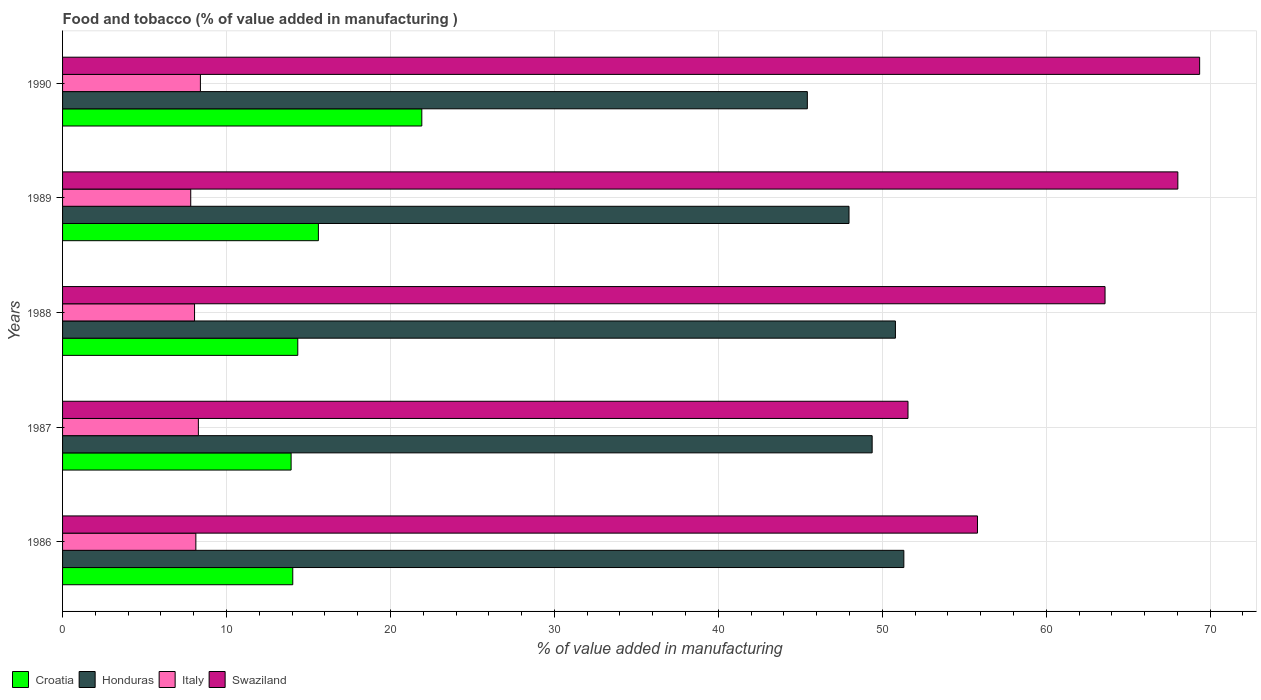Are the number of bars on each tick of the Y-axis equal?
Your answer should be compact. Yes. What is the label of the 5th group of bars from the top?
Keep it short and to the point. 1986. In how many cases, is the number of bars for a given year not equal to the number of legend labels?
Your answer should be compact. 0. What is the value added in manufacturing food and tobacco in Italy in 1988?
Give a very brief answer. 8.05. Across all years, what is the maximum value added in manufacturing food and tobacco in Honduras?
Your answer should be very brief. 51.32. Across all years, what is the minimum value added in manufacturing food and tobacco in Swaziland?
Ensure brevity in your answer.  51.57. In which year was the value added in manufacturing food and tobacco in Swaziland maximum?
Keep it short and to the point. 1990. In which year was the value added in manufacturing food and tobacco in Croatia minimum?
Ensure brevity in your answer.  1987. What is the total value added in manufacturing food and tobacco in Italy in the graph?
Make the answer very short. 40.69. What is the difference between the value added in manufacturing food and tobacco in Swaziland in 1987 and that in 1990?
Provide a succinct answer. -17.79. What is the difference between the value added in manufacturing food and tobacco in Croatia in 1989 and the value added in manufacturing food and tobacco in Italy in 1986?
Make the answer very short. 7.47. What is the average value added in manufacturing food and tobacco in Swaziland per year?
Keep it short and to the point. 61.67. In the year 1990, what is the difference between the value added in manufacturing food and tobacco in Honduras and value added in manufacturing food and tobacco in Italy?
Your response must be concise. 37.02. What is the ratio of the value added in manufacturing food and tobacco in Swaziland in 1987 to that in 1989?
Offer a terse response. 0.76. Is the difference between the value added in manufacturing food and tobacco in Honduras in 1986 and 1989 greater than the difference between the value added in manufacturing food and tobacco in Italy in 1986 and 1989?
Your answer should be very brief. Yes. What is the difference between the highest and the second highest value added in manufacturing food and tobacco in Italy?
Your answer should be very brief. 0.12. What is the difference between the highest and the lowest value added in manufacturing food and tobacco in Italy?
Provide a succinct answer. 0.59. What does the 1st bar from the top in 1988 represents?
Provide a succinct answer. Swaziland. Is it the case that in every year, the sum of the value added in manufacturing food and tobacco in Croatia and value added in manufacturing food and tobacco in Swaziland is greater than the value added in manufacturing food and tobacco in Honduras?
Make the answer very short. Yes. How many years are there in the graph?
Keep it short and to the point. 5. Are the values on the major ticks of X-axis written in scientific E-notation?
Provide a succinct answer. No. Where does the legend appear in the graph?
Offer a very short reply. Bottom left. How are the legend labels stacked?
Your answer should be compact. Horizontal. What is the title of the graph?
Offer a very short reply. Food and tobacco (% of value added in manufacturing ). Does "Zambia" appear as one of the legend labels in the graph?
Offer a terse response. No. What is the label or title of the X-axis?
Provide a succinct answer. % of value added in manufacturing. What is the label or title of the Y-axis?
Ensure brevity in your answer.  Years. What is the % of value added in manufacturing in Croatia in 1986?
Ensure brevity in your answer.  14.04. What is the % of value added in manufacturing of Honduras in 1986?
Keep it short and to the point. 51.32. What is the % of value added in manufacturing in Italy in 1986?
Keep it short and to the point. 8.13. What is the % of value added in manufacturing in Swaziland in 1986?
Your answer should be very brief. 55.81. What is the % of value added in manufacturing in Croatia in 1987?
Give a very brief answer. 13.94. What is the % of value added in manufacturing of Honduras in 1987?
Ensure brevity in your answer.  49.38. What is the % of value added in manufacturing in Italy in 1987?
Offer a very short reply. 8.28. What is the % of value added in manufacturing in Swaziland in 1987?
Offer a terse response. 51.57. What is the % of value added in manufacturing in Croatia in 1988?
Give a very brief answer. 14.35. What is the % of value added in manufacturing in Honduras in 1988?
Give a very brief answer. 50.8. What is the % of value added in manufacturing in Italy in 1988?
Provide a short and direct response. 8.05. What is the % of value added in manufacturing of Swaziland in 1988?
Your response must be concise. 63.59. What is the % of value added in manufacturing in Croatia in 1989?
Provide a succinct answer. 15.6. What is the % of value added in manufacturing in Honduras in 1989?
Your answer should be very brief. 47.97. What is the % of value added in manufacturing in Italy in 1989?
Give a very brief answer. 7.82. What is the % of value added in manufacturing of Swaziland in 1989?
Provide a succinct answer. 68.03. What is the % of value added in manufacturing in Croatia in 1990?
Offer a very short reply. 21.91. What is the % of value added in manufacturing in Honduras in 1990?
Keep it short and to the point. 45.43. What is the % of value added in manufacturing in Italy in 1990?
Give a very brief answer. 8.41. What is the % of value added in manufacturing in Swaziland in 1990?
Keep it short and to the point. 69.36. Across all years, what is the maximum % of value added in manufacturing in Croatia?
Make the answer very short. 21.91. Across all years, what is the maximum % of value added in manufacturing in Honduras?
Your answer should be compact. 51.32. Across all years, what is the maximum % of value added in manufacturing of Italy?
Provide a succinct answer. 8.41. Across all years, what is the maximum % of value added in manufacturing in Swaziland?
Your response must be concise. 69.36. Across all years, what is the minimum % of value added in manufacturing in Croatia?
Make the answer very short. 13.94. Across all years, what is the minimum % of value added in manufacturing of Honduras?
Offer a terse response. 45.43. Across all years, what is the minimum % of value added in manufacturing of Italy?
Provide a succinct answer. 7.82. Across all years, what is the minimum % of value added in manufacturing in Swaziland?
Ensure brevity in your answer.  51.57. What is the total % of value added in manufacturing of Croatia in the graph?
Give a very brief answer. 79.85. What is the total % of value added in manufacturing of Honduras in the graph?
Your answer should be very brief. 244.9. What is the total % of value added in manufacturing in Italy in the graph?
Offer a terse response. 40.69. What is the total % of value added in manufacturing of Swaziland in the graph?
Provide a succinct answer. 308.36. What is the difference between the % of value added in manufacturing of Croatia in 1986 and that in 1987?
Your response must be concise. 0.1. What is the difference between the % of value added in manufacturing of Honduras in 1986 and that in 1987?
Offer a terse response. 1.93. What is the difference between the % of value added in manufacturing in Italy in 1986 and that in 1987?
Provide a succinct answer. -0.15. What is the difference between the % of value added in manufacturing in Swaziland in 1986 and that in 1987?
Your answer should be compact. 4.24. What is the difference between the % of value added in manufacturing of Croatia in 1986 and that in 1988?
Provide a succinct answer. -0.31. What is the difference between the % of value added in manufacturing in Honduras in 1986 and that in 1988?
Keep it short and to the point. 0.51. What is the difference between the % of value added in manufacturing of Italy in 1986 and that in 1988?
Make the answer very short. 0.08. What is the difference between the % of value added in manufacturing in Swaziland in 1986 and that in 1988?
Give a very brief answer. -7.78. What is the difference between the % of value added in manufacturing of Croatia in 1986 and that in 1989?
Your answer should be compact. -1.56. What is the difference between the % of value added in manufacturing in Honduras in 1986 and that in 1989?
Keep it short and to the point. 3.34. What is the difference between the % of value added in manufacturing in Italy in 1986 and that in 1989?
Provide a succinct answer. 0.31. What is the difference between the % of value added in manufacturing in Swaziland in 1986 and that in 1989?
Give a very brief answer. -12.22. What is the difference between the % of value added in manufacturing in Croatia in 1986 and that in 1990?
Give a very brief answer. -7.87. What is the difference between the % of value added in manufacturing of Honduras in 1986 and that in 1990?
Provide a short and direct response. 5.89. What is the difference between the % of value added in manufacturing of Italy in 1986 and that in 1990?
Give a very brief answer. -0.28. What is the difference between the % of value added in manufacturing in Swaziland in 1986 and that in 1990?
Offer a very short reply. -13.55. What is the difference between the % of value added in manufacturing in Croatia in 1987 and that in 1988?
Your answer should be very brief. -0.41. What is the difference between the % of value added in manufacturing of Honduras in 1987 and that in 1988?
Keep it short and to the point. -1.42. What is the difference between the % of value added in manufacturing of Italy in 1987 and that in 1988?
Provide a succinct answer. 0.23. What is the difference between the % of value added in manufacturing in Swaziland in 1987 and that in 1988?
Offer a terse response. -12.02. What is the difference between the % of value added in manufacturing of Croatia in 1987 and that in 1989?
Provide a succinct answer. -1.66. What is the difference between the % of value added in manufacturing of Honduras in 1987 and that in 1989?
Give a very brief answer. 1.41. What is the difference between the % of value added in manufacturing in Italy in 1987 and that in 1989?
Provide a short and direct response. 0.47. What is the difference between the % of value added in manufacturing of Swaziland in 1987 and that in 1989?
Keep it short and to the point. -16.46. What is the difference between the % of value added in manufacturing of Croatia in 1987 and that in 1990?
Your answer should be very brief. -7.97. What is the difference between the % of value added in manufacturing of Honduras in 1987 and that in 1990?
Offer a very short reply. 3.95. What is the difference between the % of value added in manufacturing of Italy in 1987 and that in 1990?
Keep it short and to the point. -0.12. What is the difference between the % of value added in manufacturing in Swaziland in 1987 and that in 1990?
Give a very brief answer. -17.79. What is the difference between the % of value added in manufacturing in Croatia in 1988 and that in 1989?
Offer a terse response. -1.26. What is the difference between the % of value added in manufacturing in Honduras in 1988 and that in 1989?
Give a very brief answer. 2.83. What is the difference between the % of value added in manufacturing in Italy in 1988 and that in 1989?
Make the answer very short. 0.23. What is the difference between the % of value added in manufacturing in Swaziland in 1988 and that in 1989?
Offer a very short reply. -4.44. What is the difference between the % of value added in manufacturing in Croatia in 1988 and that in 1990?
Keep it short and to the point. -7.57. What is the difference between the % of value added in manufacturing of Honduras in 1988 and that in 1990?
Keep it short and to the point. 5.37. What is the difference between the % of value added in manufacturing of Italy in 1988 and that in 1990?
Your answer should be compact. -0.36. What is the difference between the % of value added in manufacturing in Swaziland in 1988 and that in 1990?
Ensure brevity in your answer.  -5.77. What is the difference between the % of value added in manufacturing of Croatia in 1989 and that in 1990?
Your answer should be very brief. -6.31. What is the difference between the % of value added in manufacturing in Honduras in 1989 and that in 1990?
Provide a succinct answer. 2.54. What is the difference between the % of value added in manufacturing in Italy in 1989 and that in 1990?
Your response must be concise. -0.59. What is the difference between the % of value added in manufacturing in Swaziland in 1989 and that in 1990?
Provide a succinct answer. -1.33. What is the difference between the % of value added in manufacturing in Croatia in 1986 and the % of value added in manufacturing in Honduras in 1987?
Ensure brevity in your answer.  -35.34. What is the difference between the % of value added in manufacturing of Croatia in 1986 and the % of value added in manufacturing of Italy in 1987?
Your response must be concise. 5.76. What is the difference between the % of value added in manufacturing in Croatia in 1986 and the % of value added in manufacturing in Swaziland in 1987?
Your answer should be very brief. -37.53. What is the difference between the % of value added in manufacturing of Honduras in 1986 and the % of value added in manufacturing of Italy in 1987?
Offer a very short reply. 43.03. What is the difference between the % of value added in manufacturing of Honduras in 1986 and the % of value added in manufacturing of Swaziland in 1987?
Make the answer very short. -0.25. What is the difference between the % of value added in manufacturing of Italy in 1986 and the % of value added in manufacturing of Swaziland in 1987?
Provide a short and direct response. -43.44. What is the difference between the % of value added in manufacturing in Croatia in 1986 and the % of value added in manufacturing in Honduras in 1988?
Give a very brief answer. -36.76. What is the difference between the % of value added in manufacturing in Croatia in 1986 and the % of value added in manufacturing in Italy in 1988?
Your response must be concise. 5.99. What is the difference between the % of value added in manufacturing in Croatia in 1986 and the % of value added in manufacturing in Swaziland in 1988?
Give a very brief answer. -49.55. What is the difference between the % of value added in manufacturing of Honduras in 1986 and the % of value added in manufacturing of Italy in 1988?
Provide a short and direct response. 43.27. What is the difference between the % of value added in manufacturing in Honduras in 1986 and the % of value added in manufacturing in Swaziland in 1988?
Give a very brief answer. -12.27. What is the difference between the % of value added in manufacturing of Italy in 1986 and the % of value added in manufacturing of Swaziland in 1988?
Keep it short and to the point. -55.46. What is the difference between the % of value added in manufacturing in Croatia in 1986 and the % of value added in manufacturing in Honduras in 1989?
Provide a short and direct response. -33.93. What is the difference between the % of value added in manufacturing in Croatia in 1986 and the % of value added in manufacturing in Italy in 1989?
Make the answer very short. 6.22. What is the difference between the % of value added in manufacturing of Croatia in 1986 and the % of value added in manufacturing of Swaziland in 1989?
Give a very brief answer. -53.99. What is the difference between the % of value added in manufacturing of Honduras in 1986 and the % of value added in manufacturing of Italy in 1989?
Provide a short and direct response. 43.5. What is the difference between the % of value added in manufacturing of Honduras in 1986 and the % of value added in manufacturing of Swaziland in 1989?
Offer a very short reply. -16.71. What is the difference between the % of value added in manufacturing in Italy in 1986 and the % of value added in manufacturing in Swaziland in 1989?
Your answer should be compact. -59.9. What is the difference between the % of value added in manufacturing in Croatia in 1986 and the % of value added in manufacturing in Honduras in 1990?
Your answer should be compact. -31.39. What is the difference between the % of value added in manufacturing in Croatia in 1986 and the % of value added in manufacturing in Italy in 1990?
Provide a succinct answer. 5.63. What is the difference between the % of value added in manufacturing in Croatia in 1986 and the % of value added in manufacturing in Swaziland in 1990?
Keep it short and to the point. -55.32. What is the difference between the % of value added in manufacturing in Honduras in 1986 and the % of value added in manufacturing in Italy in 1990?
Keep it short and to the point. 42.91. What is the difference between the % of value added in manufacturing in Honduras in 1986 and the % of value added in manufacturing in Swaziland in 1990?
Provide a succinct answer. -18.04. What is the difference between the % of value added in manufacturing in Italy in 1986 and the % of value added in manufacturing in Swaziland in 1990?
Provide a short and direct response. -61.23. What is the difference between the % of value added in manufacturing of Croatia in 1987 and the % of value added in manufacturing of Honduras in 1988?
Give a very brief answer. -36.86. What is the difference between the % of value added in manufacturing in Croatia in 1987 and the % of value added in manufacturing in Italy in 1988?
Make the answer very short. 5.89. What is the difference between the % of value added in manufacturing of Croatia in 1987 and the % of value added in manufacturing of Swaziland in 1988?
Keep it short and to the point. -49.65. What is the difference between the % of value added in manufacturing in Honduras in 1987 and the % of value added in manufacturing in Italy in 1988?
Make the answer very short. 41.33. What is the difference between the % of value added in manufacturing of Honduras in 1987 and the % of value added in manufacturing of Swaziland in 1988?
Offer a very short reply. -14.21. What is the difference between the % of value added in manufacturing in Italy in 1987 and the % of value added in manufacturing in Swaziland in 1988?
Make the answer very short. -55.31. What is the difference between the % of value added in manufacturing of Croatia in 1987 and the % of value added in manufacturing of Honduras in 1989?
Offer a very short reply. -34.03. What is the difference between the % of value added in manufacturing of Croatia in 1987 and the % of value added in manufacturing of Italy in 1989?
Make the answer very short. 6.12. What is the difference between the % of value added in manufacturing in Croatia in 1987 and the % of value added in manufacturing in Swaziland in 1989?
Offer a terse response. -54.09. What is the difference between the % of value added in manufacturing in Honduras in 1987 and the % of value added in manufacturing in Italy in 1989?
Provide a short and direct response. 41.56. What is the difference between the % of value added in manufacturing of Honduras in 1987 and the % of value added in manufacturing of Swaziland in 1989?
Provide a succinct answer. -18.65. What is the difference between the % of value added in manufacturing in Italy in 1987 and the % of value added in manufacturing in Swaziland in 1989?
Offer a terse response. -59.75. What is the difference between the % of value added in manufacturing in Croatia in 1987 and the % of value added in manufacturing in Honduras in 1990?
Make the answer very short. -31.49. What is the difference between the % of value added in manufacturing in Croatia in 1987 and the % of value added in manufacturing in Italy in 1990?
Your answer should be compact. 5.53. What is the difference between the % of value added in manufacturing in Croatia in 1987 and the % of value added in manufacturing in Swaziland in 1990?
Offer a very short reply. -55.42. What is the difference between the % of value added in manufacturing in Honduras in 1987 and the % of value added in manufacturing in Italy in 1990?
Your response must be concise. 40.98. What is the difference between the % of value added in manufacturing in Honduras in 1987 and the % of value added in manufacturing in Swaziland in 1990?
Provide a succinct answer. -19.98. What is the difference between the % of value added in manufacturing of Italy in 1987 and the % of value added in manufacturing of Swaziland in 1990?
Your answer should be compact. -61.08. What is the difference between the % of value added in manufacturing in Croatia in 1988 and the % of value added in manufacturing in Honduras in 1989?
Provide a short and direct response. -33.62. What is the difference between the % of value added in manufacturing in Croatia in 1988 and the % of value added in manufacturing in Italy in 1989?
Your response must be concise. 6.53. What is the difference between the % of value added in manufacturing in Croatia in 1988 and the % of value added in manufacturing in Swaziland in 1989?
Provide a succinct answer. -53.68. What is the difference between the % of value added in manufacturing of Honduras in 1988 and the % of value added in manufacturing of Italy in 1989?
Your response must be concise. 42.98. What is the difference between the % of value added in manufacturing of Honduras in 1988 and the % of value added in manufacturing of Swaziland in 1989?
Your answer should be very brief. -17.23. What is the difference between the % of value added in manufacturing in Italy in 1988 and the % of value added in manufacturing in Swaziland in 1989?
Your answer should be compact. -59.98. What is the difference between the % of value added in manufacturing in Croatia in 1988 and the % of value added in manufacturing in Honduras in 1990?
Your response must be concise. -31.08. What is the difference between the % of value added in manufacturing of Croatia in 1988 and the % of value added in manufacturing of Italy in 1990?
Offer a terse response. 5.94. What is the difference between the % of value added in manufacturing of Croatia in 1988 and the % of value added in manufacturing of Swaziland in 1990?
Provide a succinct answer. -55.01. What is the difference between the % of value added in manufacturing of Honduras in 1988 and the % of value added in manufacturing of Italy in 1990?
Offer a very short reply. 42.39. What is the difference between the % of value added in manufacturing of Honduras in 1988 and the % of value added in manufacturing of Swaziland in 1990?
Provide a short and direct response. -18.56. What is the difference between the % of value added in manufacturing of Italy in 1988 and the % of value added in manufacturing of Swaziland in 1990?
Your answer should be compact. -61.31. What is the difference between the % of value added in manufacturing of Croatia in 1989 and the % of value added in manufacturing of Honduras in 1990?
Keep it short and to the point. -29.83. What is the difference between the % of value added in manufacturing in Croatia in 1989 and the % of value added in manufacturing in Italy in 1990?
Ensure brevity in your answer.  7.2. What is the difference between the % of value added in manufacturing of Croatia in 1989 and the % of value added in manufacturing of Swaziland in 1990?
Your answer should be compact. -53.75. What is the difference between the % of value added in manufacturing of Honduras in 1989 and the % of value added in manufacturing of Italy in 1990?
Offer a terse response. 39.56. What is the difference between the % of value added in manufacturing of Honduras in 1989 and the % of value added in manufacturing of Swaziland in 1990?
Keep it short and to the point. -21.39. What is the difference between the % of value added in manufacturing in Italy in 1989 and the % of value added in manufacturing in Swaziland in 1990?
Make the answer very short. -61.54. What is the average % of value added in manufacturing of Croatia per year?
Give a very brief answer. 15.97. What is the average % of value added in manufacturing in Honduras per year?
Provide a short and direct response. 48.98. What is the average % of value added in manufacturing of Italy per year?
Offer a very short reply. 8.14. What is the average % of value added in manufacturing in Swaziland per year?
Keep it short and to the point. 61.67. In the year 1986, what is the difference between the % of value added in manufacturing in Croatia and % of value added in manufacturing in Honduras?
Offer a terse response. -37.27. In the year 1986, what is the difference between the % of value added in manufacturing in Croatia and % of value added in manufacturing in Italy?
Keep it short and to the point. 5.91. In the year 1986, what is the difference between the % of value added in manufacturing of Croatia and % of value added in manufacturing of Swaziland?
Provide a succinct answer. -41.77. In the year 1986, what is the difference between the % of value added in manufacturing of Honduras and % of value added in manufacturing of Italy?
Your response must be concise. 43.19. In the year 1986, what is the difference between the % of value added in manufacturing of Honduras and % of value added in manufacturing of Swaziland?
Your answer should be very brief. -4.49. In the year 1986, what is the difference between the % of value added in manufacturing of Italy and % of value added in manufacturing of Swaziland?
Provide a succinct answer. -47.68. In the year 1987, what is the difference between the % of value added in manufacturing in Croatia and % of value added in manufacturing in Honduras?
Your answer should be compact. -35.44. In the year 1987, what is the difference between the % of value added in manufacturing of Croatia and % of value added in manufacturing of Italy?
Keep it short and to the point. 5.66. In the year 1987, what is the difference between the % of value added in manufacturing in Croatia and % of value added in manufacturing in Swaziland?
Your answer should be compact. -37.63. In the year 1987, what is the difference between the % of value added in manufacturing of Honduras and % of value added in manufacturing of Italy?
Give a very brief answer. 41.1. In the year 1987, what is the difference between the % of value added in manufacturing in Honduras and % of value added in manufacturing in Swaziland?
Your response must be concise. -2.19. In the year 1987, what is the difference between the % of value added in manufacturing of Italy and % of value added in manufacturing of Swaziland?
Ensure brevity in your answer.  -43.29. In the year 1988, what is the difference between the % of value added in manufacturing of Croatia and % of value added in manufacturing of Honduras?
Give a very brief answer. -36.46. In the year 1988, what is the difference between the % of value added in manufacturing of Croatia and % of value added in manufacturing of Italy?
Your answer should be very brief. 6.3. In the year 1988, what is the difference between the % of value added in manufacturing of Croatia and % of value added in manufacturing of Swaziland?
Provide a succinct answer. -49.24. In the year 1988, what is the difference between the % of value added in manufacturing of Honduras and % of value added in manufacturing of Italy?
Keep it short and to the point. 42.75. In the year 1988, what is the difference between the % of value added in manufacturing of Honduras and % of value added in manufacturing of Swaziland?
Your answer should be very brief. -12.79. In the year 1988, what is the difference between the % of value added in manufacturing of Italy and % of value added in manufacturing of Swaziland?
Offer a very short reply. -55.54. In the year 1989, what is the difference between the % of value added in manufacturing of Croatia and % of value added in manufacturing of Honduras?
Offer a very short reply. -32.37. In the year 1989, what is the difference between the % of value added in manufacturing in Croatia and % of value added in manufacturing in Italy?
Offer a terse response. 7.79. In the year 1989, what is the difference between the % of value added in manufacturing in Croatia and % of value added in manufacturing in Swaziland?
Make the answer very short. -52.43. In the year 1989, what is the difference between the % of value added in manufacturing in Honduras and % of value added in manufacturing in Italy?
Give a very brief answer. 40.15. In the year 1989, what is the difference between the % of value added in manufacturing in Honduras and % of value added in manufacturing in Swaziland?
Keep it short and to the point. -20.06. In the year 1989, what is the difference between the % of value added in manufacturing in Italy and % of value added in manufacturing in Swaziland?
Give a very brief answer. -60.21. In the year 1990, what is the difference between the % of value added in manufacturing of Croatia and % of value added in manufacturing of Honduras?
Make the answer very short. -23.52. In the year 1990, what is the difference between the % of value added in manufacturing of Croatia and % of value added in manufacturing of Italy?
Offer a terse response. 13.5. In the year 1990, what is the difference between the % of value added in manufacturing in Croatia and % of value added in manufacturing in Swaziland?
Make the answer very short. -47.45. In the year 1990, what is the difference between the % of value added in manufacturing in Honduras and % of value added in manufacturing in Italy?
Your answer should be compact. 37.02. In the year 1990, what is the difference between the % of value added in manufacturing of Honduras and % of value added in manufacturing of Swaziland?
Ensure brevity in your answer.  -23.93. In the year 1990, what is the difference between the % of value added in manufacturing of Italy and % of value added in manufacturing of Swaziland?
Your answer should be compact. -60.95. What is the ratio of the % of value added in manufacturing of Honduras in 1986 to that in 1987?
Make the answer very short. 1.04. What is the ratio of the % of value added in manufacturing in Italy in 1986 to that in 1987?
Your answer should be compact. 0.98. What is the ratio of the % of value added in manufacturing in Swaziland in 1986 to that in 1987?
Make the answer very short. 1.08. What is the ratio of the % of value added in manufacturing in Croatia in 1986 to that in 1988?
Your response must be concise. 0.98. What is the ratio of the % of value added in manufacturing of Italy in 1986 to that in 1988?
Offer a terse response. 1.01. What is the ratio of the % of value added in manufacturing in Swaziland in 1986 to that in 1988?
Your answer should be compact. 0.88. What is the ratio of the % of value added in manufacturing in Croatia in 1986 to that in 1989?
Your answer should be compact. 0.9. What is the ratio of the % of value added in manufacturing of Honduras in 1986 to that in 1989?
Make the answer very short. 1.07. What is the ratio of the % of value added in manufacturing of Italy in 1986 to that in 1989?
Ensure brevity in your answer.  1.04. What is the ratio of the % of value added in manufacturing of Swaziland in 1986 to that in 1989?
Your response must be concise. 0.82. What is the ratio of the % of value added in manufacturing of Croatia in 1986 to that in 1990?
Offer a terse response. 0.64. What is the ratio of the % of value added in manufacturing in Honduras in 1986 to that in 1990?
Offer a terse response. 1.13. What is the ratio of the % of value added in manufacturing in Swaziland in 1986 to that in 1990?
Give a very brief answer. 0.8. What is the ratio of the % of value added in manufacturing of Croatia in 1987 to that in 1988?
Provide a short and direct response. 0.97. What is the ratio of the % of value added in manufacturing in Honduras in 1987 to that in 1988?
Your response must be concise. 0.97. What is the ratio of the % of value added in manufacturing in Swaziland in 1987 to that in 1988?
Make the answer very short. 0.81. What is the ratio of the % of value added in manufacturing of Croatia in 1987 to that in 1989?
Make the answer very short. 0.89. What is the ratio of the % of value added in manufacturing of Honduras in 1987 to that in 1989?
Your response must be concise. 1.03. What is the ratio of the % of value added in manufacturing in Italy in 1987 to that in 1989?
Keep it short and to the point. 1.06. What is the ratio of the % of value added in manufacturing of Swaziland in 1987 to that in 1989?
Keep it short and to the point. 0.76. What is the ratio of the % of value added in manufacturing in Croatia in 1987 to that in 1990?
Your answer should be compact. 0.64. What is the ratio of the % of value added in manufacturing of Honduras in 1987 to that in 1990?
Provide a succinct answer. 1.09. What is the ratio of the % of value added in manufacturing in Italy in 1987 to that in 1990?
Your answer should be very brief. 0.99. What is the ratio of the % of value added in manufacturing in Swaziland in 1987 to that in 1990?
Provide a succinct answer. 0.74. What is the ratio of the % of value added in manufacturing of Croatia in 1988 to that in 1989?
Keep it short and to the point. 0.92. What is the ratio of the % of value added in manufacturing of Honduras in 1988 to that in 1989?
Your answer should be very brief. 1.06. What is the ratio of the % of value added in manufacturing in Italy in 1988 to that in 1989?
Make the answer very short. 1.03. What is the ratio of the % of value added in manufacturing of Swaziland in 1988 to that in 1989?
Provide a succinct answer. 0.93. What is the ratio of the % of value added in manufacturing in Croatia in 1988 to that in 1990?
Provide a short and direct response. 0.65. What is the ratio of the % of value added in manufacturing of Honduras in 1988 to that in 1990?
Your answer should be compact. 1.12. What is the ratio of the % of value added in manufacturing of Italy in 1988 to that in 1990?
Keep it short and to the point. 0.96. What is the ratio of the % of value added in manufacturing in Swaziland in 1988 to that in 1990?
Your answer should be compact. 0.92. What is the ratio of the % of value added in manufacturing of Croatia in 1989 to that in 1990?
Give a very brief answer. 0.71. What is the ratio of the % of value added in manufacturing in Honduras in 1989 to that in 1990?
Your answer should be compact. 1.06. What is the ratio of the % of value added in manufacturing in Italy in 1989 to that in 1990?
Provide a succinct answer. 0.93. What is the ratio of the % of value added in manufacturing in Swaziland in 1989 to that in 1990?
Your answer should be compact. 0.98. What is the difference between the highest and the second highest % of value added in manufacturing in Croatia?
Your answer should be very brief. 6.31. What is the difference between the highest and the second highest % of value added in manufacturing in Honduras?
Your answer should be very brief. 0.51. What is the difference between the highest and the second highest % of value added in manufacturing of Italy?
Your response must be concise. 0.12. What is the difference between the highest and the second highest % of value added in manufacturing in Swaziland?
Give a very brief answer. 1.33. What is the difference between the highest and the lowest % of value added in manufacturing in Croatia?
Your answer should be compact. 7.97. What is the difference between the highest and the lowest % of value added in manufacturing of Honduras?
Make the answer very short. 5.89. What is the difference between the highest and the lowest % of value added in manufacturing of Italy?
Offer a terse response. 0.59. What is the difference between the highest and the lowest % of value added in manufacturing of Swaziland?
Make the answer very short. 17.79. 